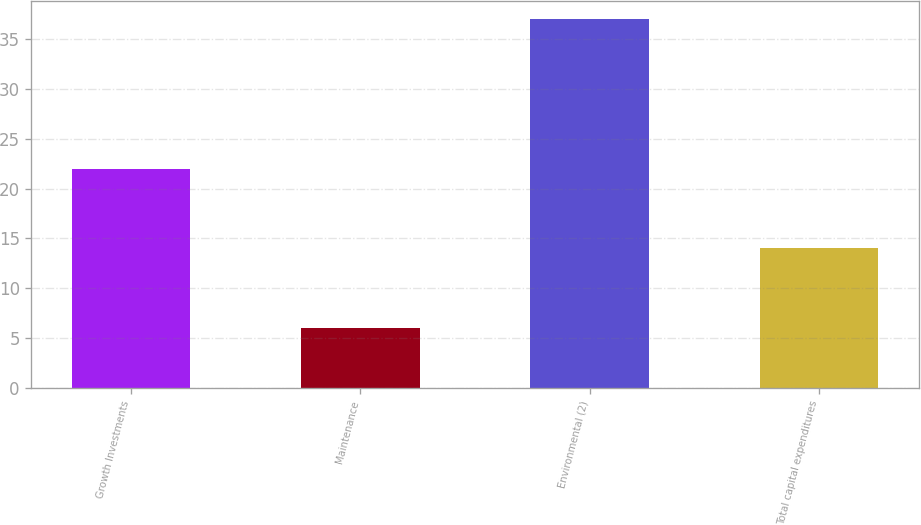<chart> <loc_0><loc_0><loc_500><loc_500><bar_chart><fcel>Growth Investments<fcel>Maintenance<fcel>Environmental (2)<fcel>Total capital expenditures<nl><fcel>22<fcel>6<fcel>37<fcel>14<nl></chart> 